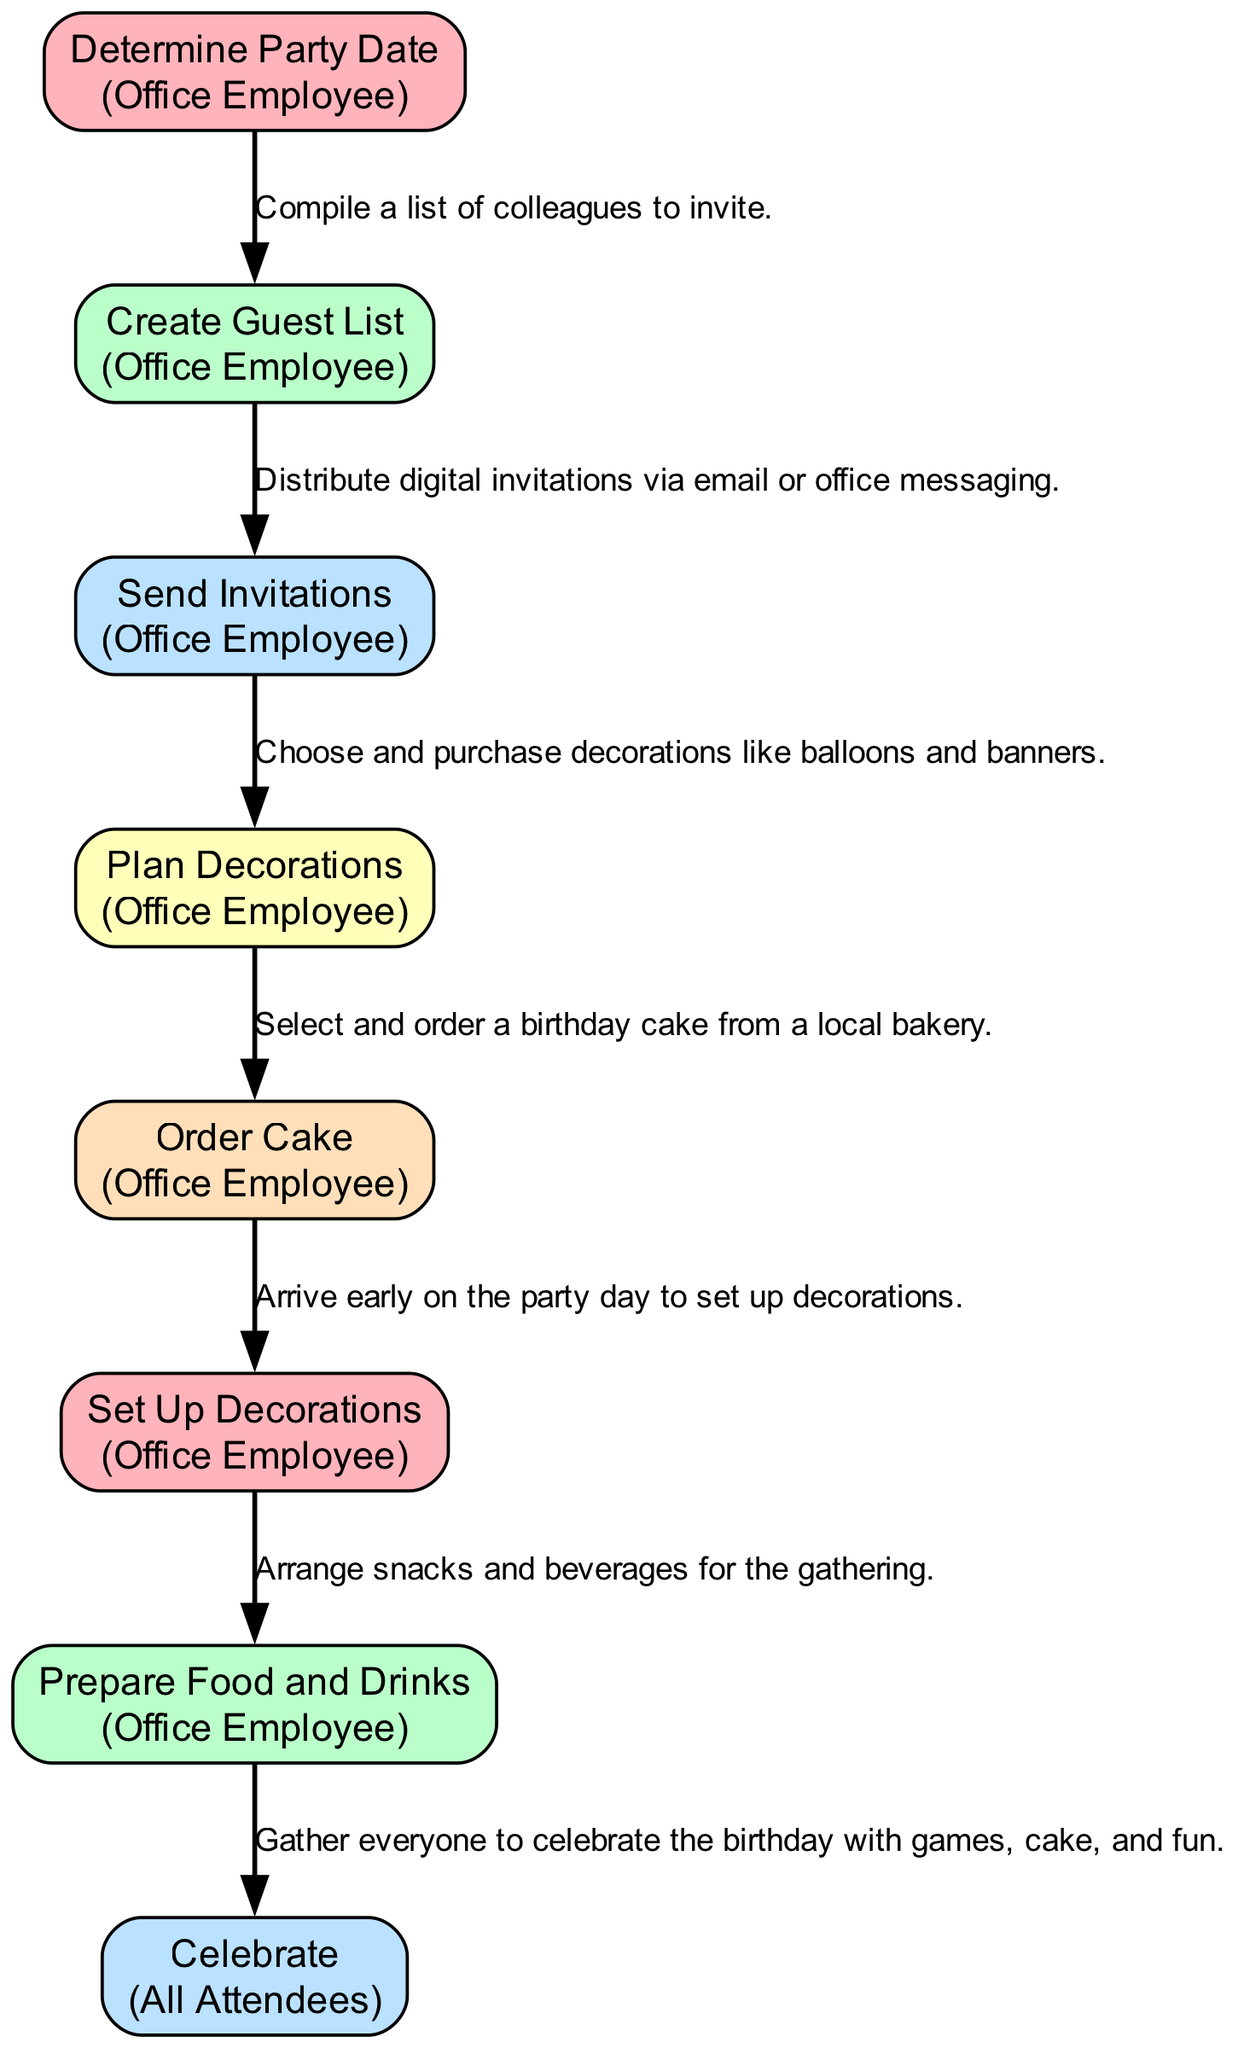What is the first action in the sequence? The first action listed is "Determine Party Date," according to the order of steps in the diagram.
Answer: Determine Party Date Who is responsible for all the actions? Each action has the "Office Employee" listed as responsible except for the last step, which involves "All Attendees." The majority of tasks fall under the Office Employee's responsibility.
Answer: Office Employee What decoration is planned in this sequence? The steps mention "Plan Decorations" and involves selecting decorations like balloons and banners as specified in the action description.
Answer: Plan Decorations How many total actions are there in the diagram? The actions list comprises eight distinct steps, as seen from the provided data.
Answer: Eight Which action involves food arrangements? The "Prepare Food and Drinks" step specifically addresses arranging snacks and beverages for the gathering.
Answer: Prepare Food and Drinks What action comes after "Send Invitations"? The next action after "Send Invitations" is "Plan Decorations," establishing the flow of the sequence.
Answer: Plan Decorations Who is involved in the celebration? The last action in the diagram states that "All Attendees" participate in the celebration. Therefore, they are involved in this part of the sequence.
Answer: All Attendees What is the main objective of the entire sequence? The collective actions lead to an "office birthday party," with planning and execution culminating in a celebratory gathering.
Answer: Office birthday party Which step requires early arrival on the party day? The "Set Up Decorations" action indicates that someone must arrive early to prepare the party environment before guests arrive.
Answer: Set Up Decorations 